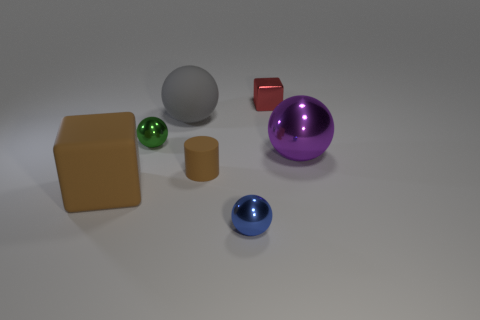There is a large object that is behind the purple metal object; is its shape the same as the metallic object to the left of the big gray matte sphere?
Offer a very short reply. Yes. What number of objects are large gray objects or purple metallic balls?
Provide a short and direct response. 2. What color is the cylinder that is the same size as the red cube?
Ensure brevity in your answer.  Brown. What number of green shiny objects are in front of the large rubber thing that is in front of the green ball?
Offer a very short reply. 0. What number of small things are both behind the blue sphere and right of the cylinder?
Give a very brief answer. 1. What number of things are cubes behind the large cube or rubber things that are in front of the large metallic thing?
Offer a very short reply. 3. How many other objects are there of the same size as the purple sphere?
Your answer should be very brief. 2. The tiny metallic thing to the left of the tiny sphere that is in front of the purple ball is what shape?
Offer a very short reply. Sphere. Do the cube that is left of the red metallic block and the cube to the right of the green object have the same color?
Make the answer very short. No. Is there any other thing of the same color as the tiny rubber cylinder?
Your response must be concise. Yes. 